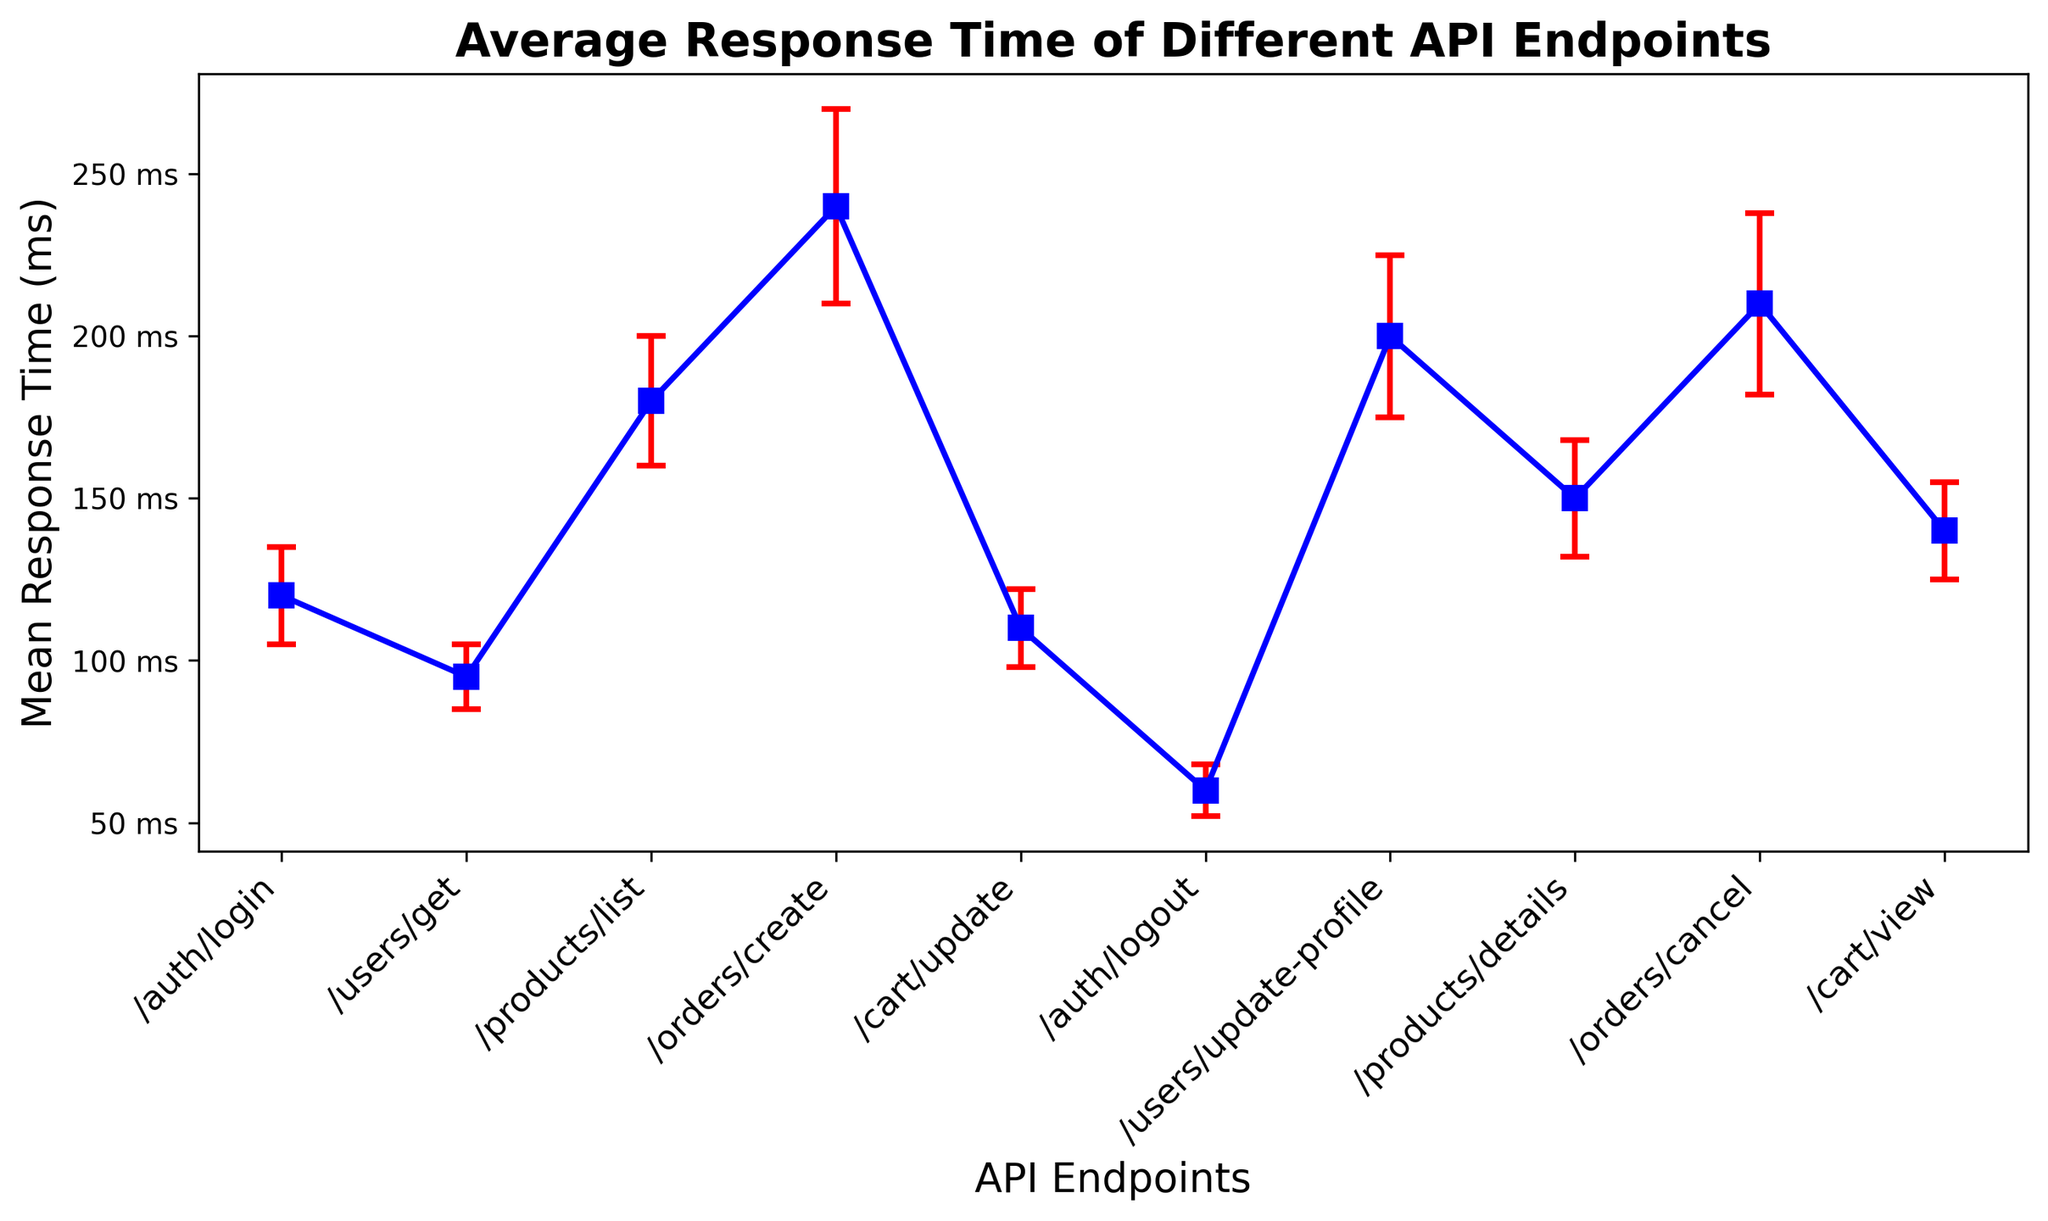Which API endpoint has the highest mean response time? By looking at the heights of the markers along the y-axis, the 'orders/create' endpoint has the highest point.
Answer: orders/create Which API endpoint has the lowest mean response time? By looking at the heights of the markers along the y-axis, the 'auth/logout' endpoint has the lowest point.
Answer: auth/logout What is the difference in mean response time between 'products/details' and 'users/update-profile'? The mean response time for 'products/details' is 150 ms and for 'users/update-profile' is 200 ms. The difference is 200 - 150.
Answer: 50 ms What is the average response time of 'users/get', 'cart/view', and 'auth/login' endpoints? The mean response times are 95 ms (users/get), 140 ms (cart/view), and 120 ms (auth/login). Their average is (95 + 140 + 120) / 3.
Answer: 118.33 ms Which API endpoint has the largest error margin? By looking at the size of the red error bars, the 'orders/create' endpoint has the longest error bar.
Answer: orders/create How does the mean response time of 'products/list' compare to 'cart/update'? The mean response time of 'products/list' is 180 ms and for 'cart/update' is 110 ms. The 'products/list' endpoint takes longer.
Answer: products/list is slower What is the total mean response time for 'orders/create' and 'orders/cancel'? The mean response times are 240 ms for 'orders/create' and 210 ms for 'orders/cancel'. Their total is 240 + 210.
Answer: 450 ms Are the mean response times of any endpoints the same? By examining the heights of the markers, none of the endpoints have the same mean response time.
Answer: No Which endpoint has the mean response time closest to the overall average of all endpoints? Calculate the overall average: (120 + 95 + 180 + 240 + 110 + 60 + 200 + 150 + 210 + 140)/10 = 150.5. 'products/details' with 150 ms is closest.
Answer: products/details 